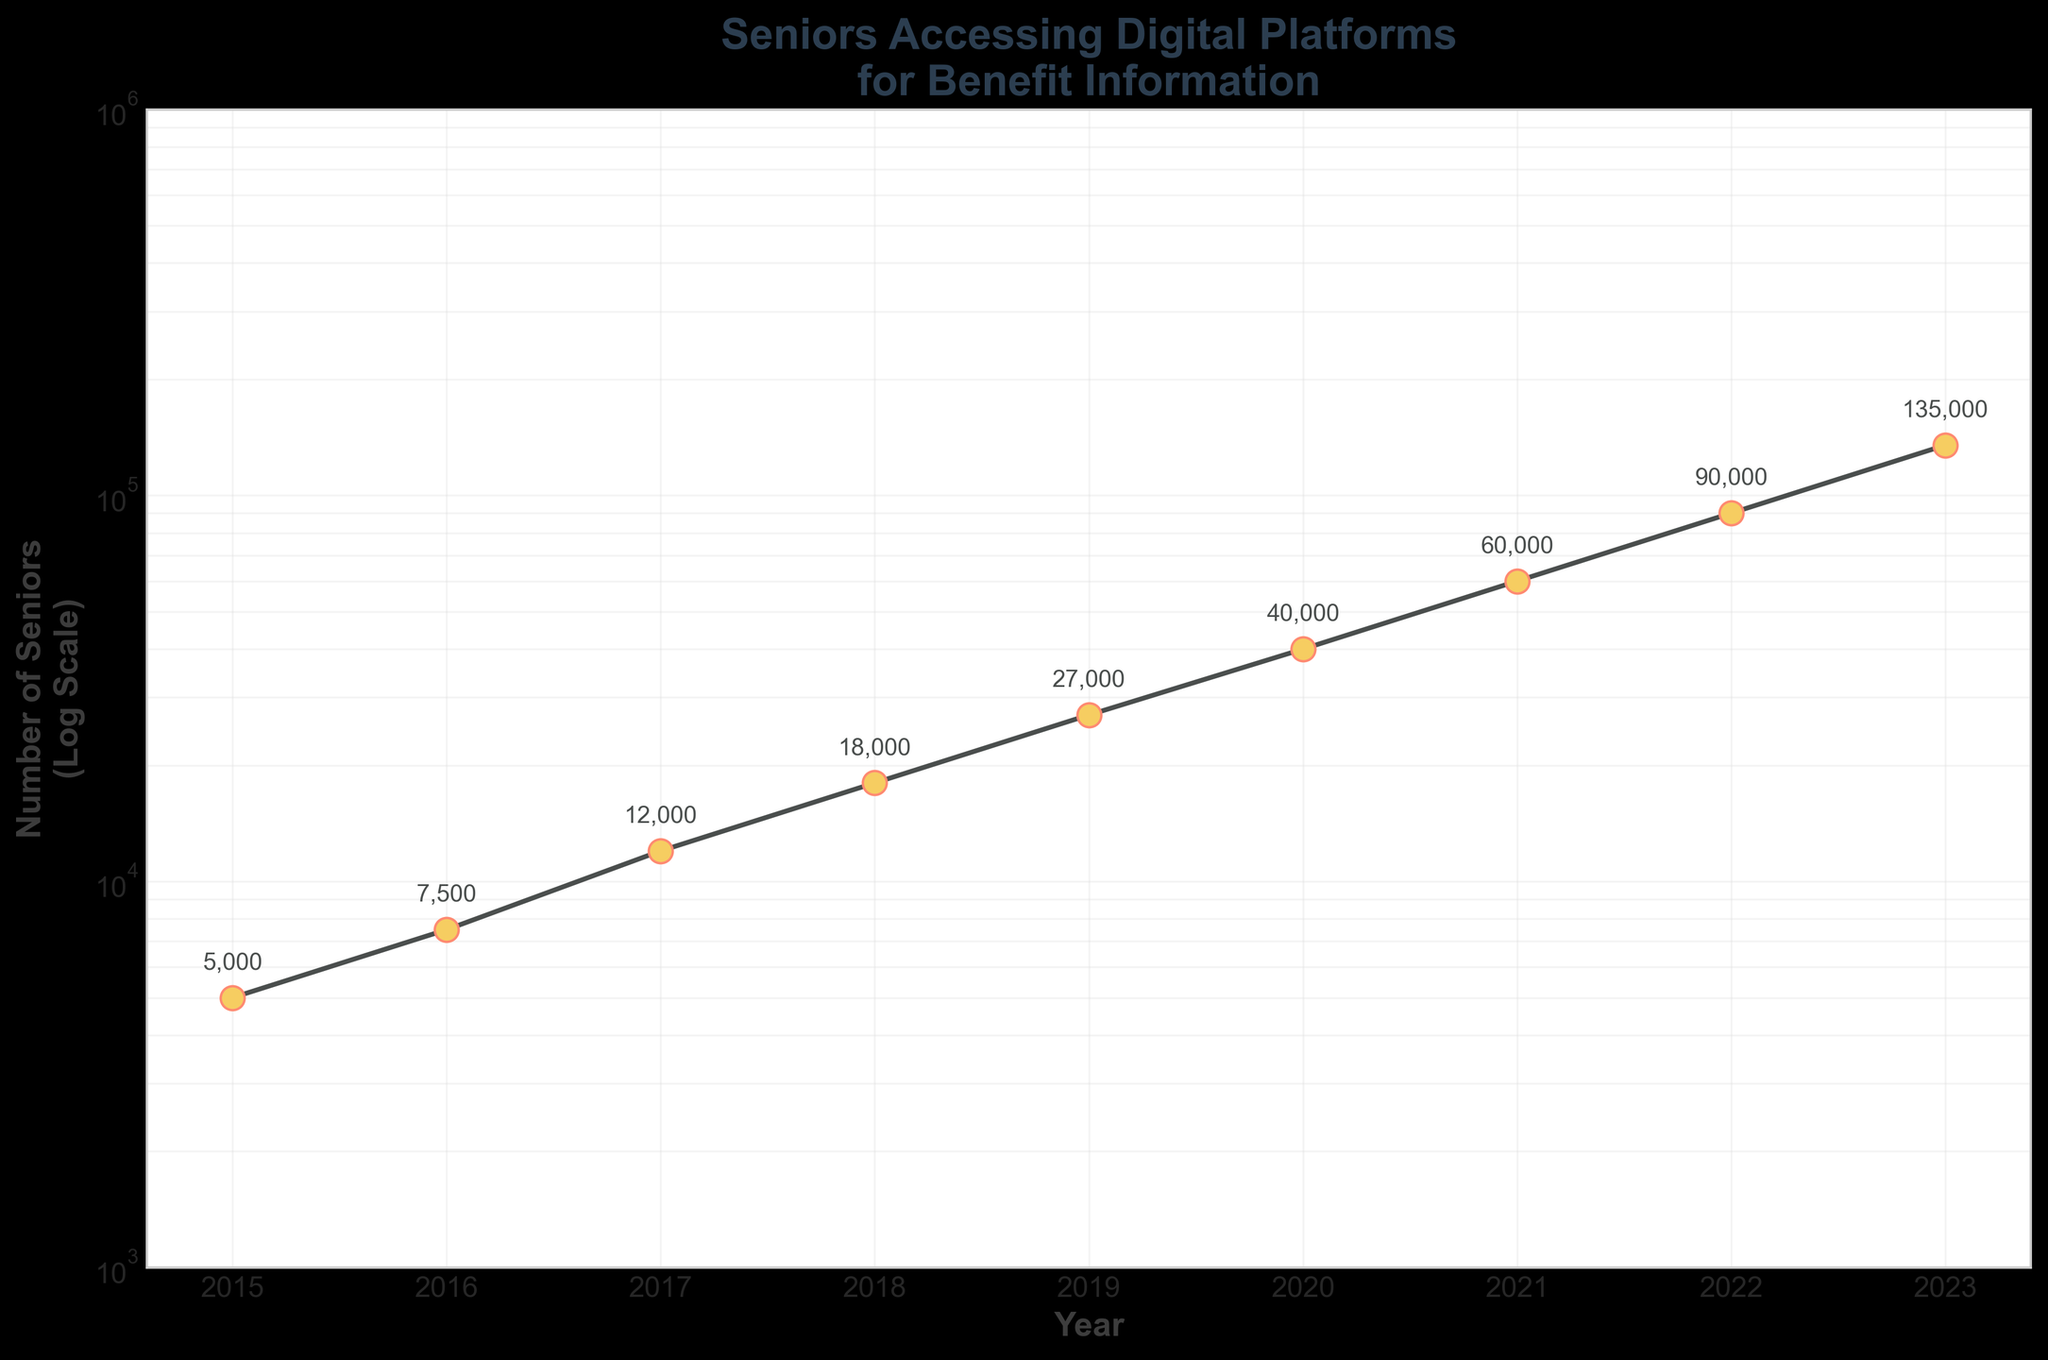what is the title of the plot? The title of the plot is located at the top of the figure and provides an overview of what the graph represents. The title here reads "Seniors Accessing Digital Platforms for Benefit Information".
Answer: Seniors Accessing Digital Platforms for Benefit Information How many years are displayed on this plot? The x-axis label represents the years. By counting the tick marks or points, we see there are 9 years displayed (from 2015 to 2023).
Answer: 9 What was the number of seniors accessing digital platforms in 2019? Look at the point where the year 2019 is marked, and check the annotated number next to the plot point. It reads "27000".
Answer: 27000 Is the number of seniors using digital platforms for benefit information increasing or decreasing over time? To determine the trend, observe the graphical line connecting each year's data point. The line moves upwards from left to right, indicating an increase over time.
Answer: Increasing Which year had the highest number of seniors accessing digital platforms? Locate the highest point on the plot, which is annotated with the number 135000. Looking downwards from this point, it intersects with the year 2023 on the x-axis.
Answer: 2023 How much did the number of seniors increase from 2018 to 2022? Identify the numbers for 2018 and 2022 from the plot (18000 and 90000 respectively). Subtract the 2018 value from the 2022 value: 90000 - 18000 = 72000.
Answer: 72000 By what factor did the number of seniors grow from 2016 to 2020? Find the numbers for these years on the plot. Seniors in 2016: 7500, and seniors in 2020: 40000. The factor is given by dividing 40000 by 7500: 40000 / 7500 = 5.33.
Answer: 5.33 Between which consecutive years was the largest increase in the number of seniors accessing digital platforms? Calculate the differences year-by-year: (7500-5000), (12000-7500), (18000-12000), (27000-18000), (40000-27000), (60000-40000), (90000-60000), (135000-90000). The largest difference is 45000 between 2022 and 2023.
Answer: Between 2022 and 2023 What is the approximate average yearly growth in the number of seniors accessing digital platforms from 2015 to 2023? Sum all the data points: 5000 + 7500 + 12000 + 18000 + 27000 + 40000 + 60000 + 90000 + 135000 = 409500. Divide by the number of years: 409500 / 9 ≈ 45500.
Answer: 45500 